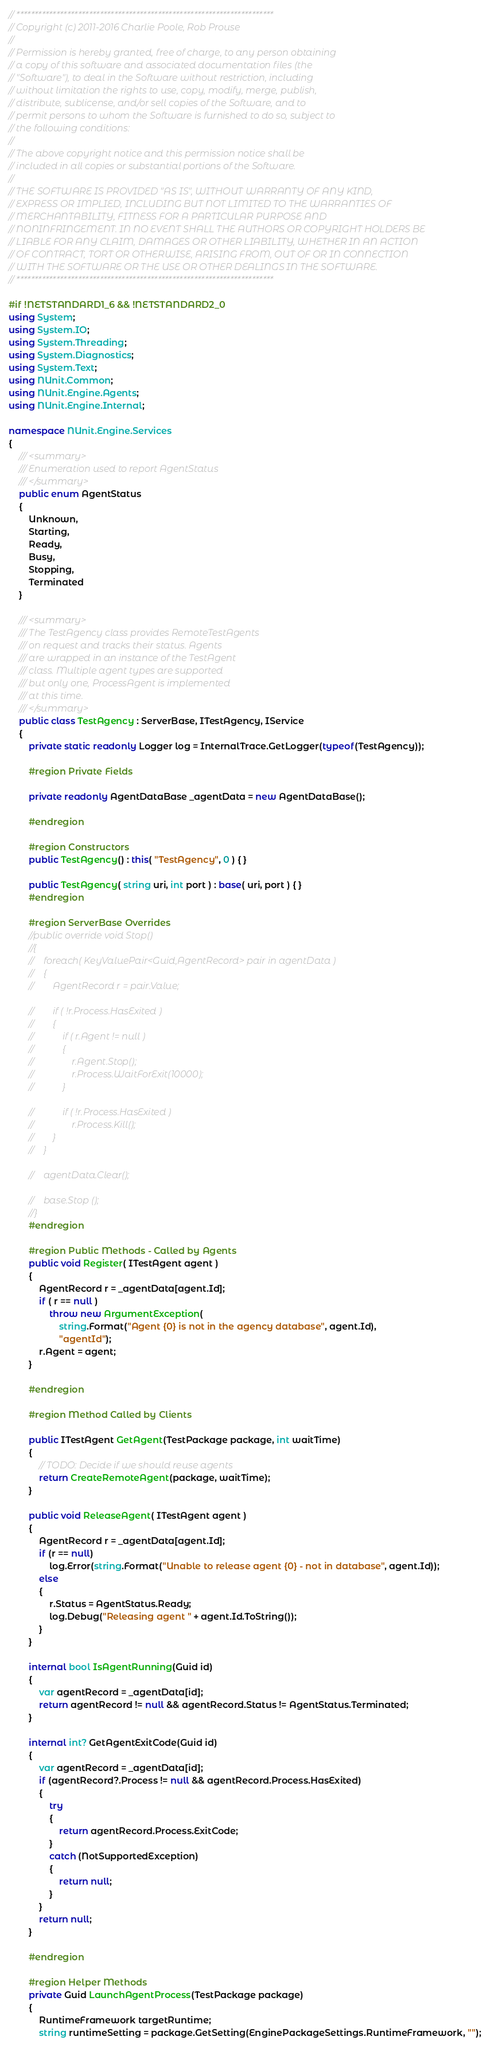<code> <loc_0><loc_0><loc_500><loc_500><_C#_>// ***********************************************************************
// Copyright (c) 2011-2016 Charlie Poole, Rob Prouse
//
// Permission is hereby granted, free of charge, to any person obtaining
// a copy of this software and associated documentation files (the
// "Software"), to deal in the Software without restriction, including
// without limitation the rights to use, copy, modify, merge, publish,
// distribute, sublicense, and/or sell copies of the Software, and to
// permit persons to whom the Software is furnished to do so, subject to
// the following conditions:
//
// The above copyright notice and this permission notice shall be
// included in all copies or substantial portions of the Software.
//
// THE SOFTWARE IS PROVIDED "AS IS", WITHOUT WARRANTY OF ANY KIND,
// EXPRESS OR IMPLIED, INCLUDING BUT NOT LIMITED TO THE WARRANTIES OF
// MERCHANTABILITY, FITNESS FOR A PARTICULAR PURPOSE AND
// NONINFRINGEMENT. IN NO EVENT SHALL THE AUTHORS OR COPYRIGHT HOLDERS BE
// LIABLE FOR ANY CLAIM, DAMAGES OR OTHER LIABILITY, WHETHER IN AN ACTION
// OF CONTRACT, TORT OR OTHERWISE, ARISING FROM, OUT OF OR IN CONNECTION
// WITH THE SOFTWARE OR THE USE OR OTHER DEALINGS IN THE SOFTWARE.
// ***********************************************************************

#if !NETSTANDARD1_6 && !NETSTANDARD2_0
using System;
using System.IO;
using System.Threading;
using System.Diagnostics;
using System.Text;
using NUnit.Common;
using NUnit.Engine.Agents;
using NUnit.Engine.Internal;

namespace NUnit.Engine.Services
{
    /// <summary>
    /// Enumeration used to report AgentStatus
    /// </summary>
    public enum AgentStatus
    {
        Unknown,
        Starting,
        Ready,
        Busy,
        Stopping,
        Terminated
    }

    /// <summary>
    /// The TestAgency class provides RemoteTestAgents
    /// on request and tracks their status. Agents
    /// are wrapped in an instance of the TestAgent
    /// class. Multiple agent types are supported
    /// but only one, ProcessAgent is implemented
    /// at this time.
    /// </summary>
    public class TestAgency : ServerBase, ITestAgency, IService
    {
        private static readonly Logger log = InternalTrace.GetLogger(typeof(TestAgency));

        #region Private Fields

        private readonly AgentDataBase _agentData = new AgentDataBase();

        #endregion

        #region Constructors
        public TestAgency() : this( "TestAgency", 0 ) { }

        public TestAgency( string uri, int port ) : base( uri, port ) { }
        #endregion

        #region ServerBase Overrides
        //public override void Stop()
        //{
        //    foreach( KeyValuePair<Guid,AgentRecord> pair in agentData )
        //    {
        //        AgentRecord r = pair.Value;

        //        if ( !r.Process.HasExited )
        //        {
        //            if ( r.Agent != null )
        //            {
        //                r.Agent.Stop();
        //                r.Process.WaitForExit(10000);
        //            }

        //            if ( !r.Process.HasExited )
        //                r.Process.Kill();
        //        }
        //    }

        //    agentData.Clear();

        //    base.Stop ();
        //}
        #endregion

        #region Public Methods - Called by Agents
        public void Register( ITestAgent agent )
        {
            AgentRecord r = _agentData[agent.Id];
            if ( r == null )
                throw new ArgumentException(
                    string.Format("Agent {0} is not in the agency database", agent.Id),
                    "agentId");
            r.Agent = agent;
        }

        #endregion

        #region Method Called by Clients

        public ITestAgent GetAgent(TestPackage package, int waitTime)
        {
            // TODO: Decide if we should reuse agents
            return CreateRemoteAgent(package, waitTime);
        }

        public void ReleaseAgent( ITestAgent agent )
        {
            AgentRecord r = _agentData[agent.Id];
            if (r == null)
                log.Error(string.Format("Unable to release agent {0} - not in database", agent.Id));
            else
            {
                r.Status = AgentStatus.Ready;
                log.Debug("Releasing agent " + agent.Id.ToString());
            }
        }

        internal bool IsAgentRunning(Guid id)
        {
            var agentRecord = _agentData[id];
            return agentRecord != null && agentRecord.Status != AgentStatus.Terminated;
        }

        internal int? GetAgentExitCode(Guid id)
        {
            var agentRecord = _agentData[id];
            if (agentRecord?.Process != null && agentRecord.Process.HasExited)
            {
                try
                {
                    return agentRecord.Process.ExitCode;
                }
                catch (NotSupportedException)
                {
                    return null;
                }
            }
            return null;
        }

        #endregion

        #region Helper Methods
        private Guid LaunchAgentProcess(TestPackage package)
        {
            RuntimeFramework targetRuntime;
            string runtimeSetting = package.GetSetting(EnginePackageSettings.RuntimeFramework, "");</code> 